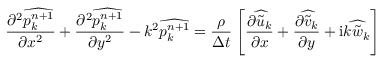<formula> <loc_0><loc_0><loc_500><loc_500>\frac { \partial ^ { 2 } \widehat { p _ { k } ^ { n + 1 } } } { \partial x ^ { 2 } } + \frac { \partial ^ { 2 } \widehat { p _ { k } ^ { n + 1 } } } { \partial y ^ { 2 } } - k ^ { 2 } \widehat { p _ { k } ^ { n + 1 } } = \frac { \rho } { \Delta t } \left [ \frac { \partial \widehat { \tilde { u } _ { k } } } { \partial x } + \frac { \partial \widehat { \tilde { v } _ { k } } } { \partial y } + i k \widehat { \tilde { w } _ { k } } \right ]</formula> 